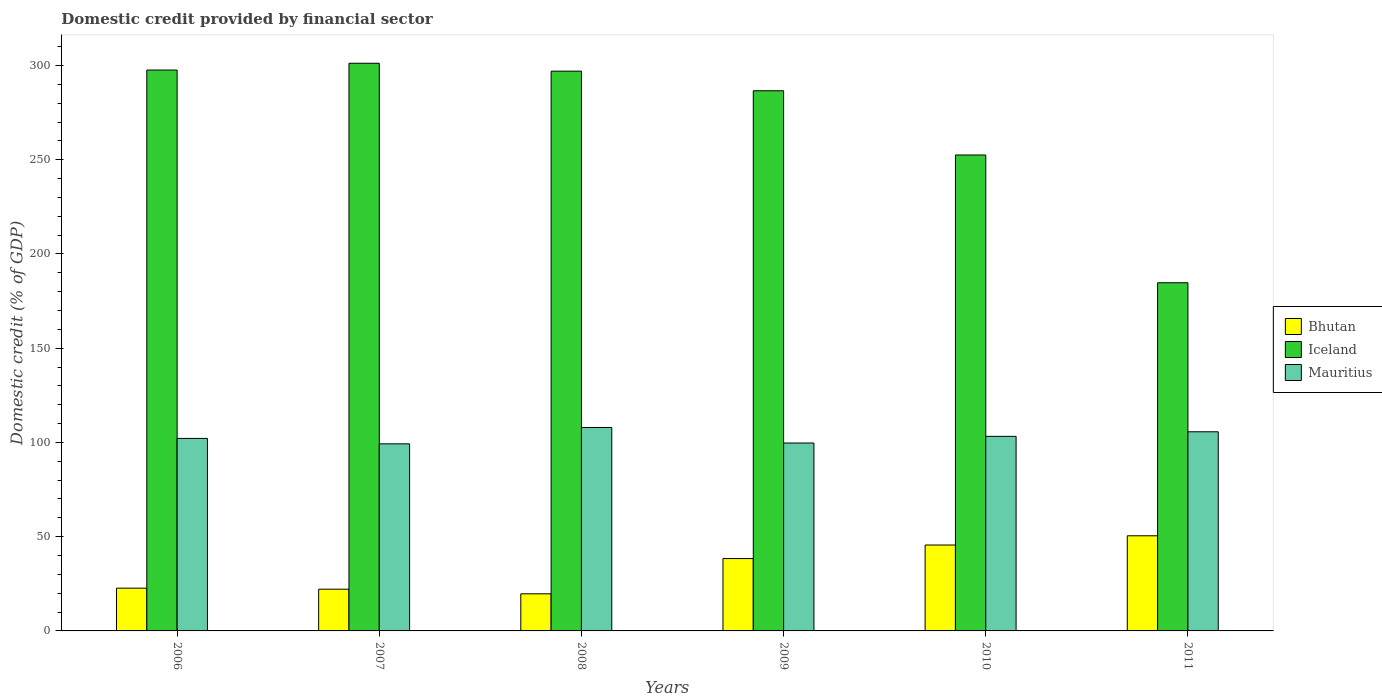How many different coloured bars are there?
Your response must be concise. 3. How many groups of bars are there?
Ensure brevity in your answer.  6. Are the number of bars per tick equal to the number of legend labels?
Your response must be concise. Yes. What is the domestic credit in Mauritius in 2011?
Your response must be concise. 105.66. Across all years, what is the maximum domestic credit in Bhutan?
Provide a succinct answer. 50.47. Across all years, what is the minimum domestic credit in Bhutan?
Offer a terse response. 19.68. In which year was the domestic credit in Mauritius maximum?
Your answer should be very brief. 2008. What is the total domestic credit in Mauritius in the graph?
Your answer should be compact. 617.94. What is the difference between the domestic credit in Iceland in 2006 and that in 2008?
Keep it short and to the point. 0.58. What is the difference between the domestic credit in Bhutan in 2009 and the domestic credit in Mauritius in 2006?
Your answer should be compact. -63.75. What is the average domestic credit in Bhutan per year?
Keep it short and to the point. 33.16. In the year 2006, what is the difference between the domestic credit in Mauritius and domestic credit in Bhutan?
Ensure brevity in your answer.  79.45. In how many years, is the domestic credit in Mauritius greater than 50 %?
Make the answer very short. 6. What is the ratio of the domestic credit in Mauritius in 2006 to that in 2010?
Provide a short and direct response. 0.99. Is the domestic credit in Bhutan in 2008 less than that in 2011?
Your answer should be very brief. Yes. Is the difference between the domestic credit in Mauritius in 2009 and 2011 greater than the difference between the domestic credit in Bhutan in 2009 and 2011?
Your answer should be compact. Yes. What is the difference between the highest and the second highest domestic credit in Iceland?
Your answer should be compact. 3.6. What is the difference between the highest and the lowest domestic credit in Bhutan?
Provide a short and direct response. 30.79. In how many years, is the domestic credit in Bhutan greater than the average domestic credit in Bhutan taken over all years?
Ensure brevity in your answer.  3. Is the sum of the domestic credit in Iceland in 2008 and 2011 greater than the maximum domestic credit in Bhutan across all years?
Give a very brief answer. Yes. What does the 1st bar from the left in 2009 represents?
Your answer should be compact. Bhutan. What does the 3rd bar from the right in 2006 represents?
Keep it short and to the point. Bhutan. Is it the case that in every year, the sum of the domestic credit in Bhutan and domestic credit in Iceland is greater than the domestic credit in Mauritius?
Make the answer very short. Yes. How many bars are there?
Give a very brief answer. 18. What is the difference between two consecutive major ticks on the Y-axis?
Provide a short and direct response. 50. Are the values on the major ticks of Y-axis written in scientific E-notation?
Give a very brief answer. No. Does the graph contain any zero values?
Your answer should be very brief. No. Where does the legend appear in the graph?
Make the answer very short. Center right. How many legend labels are there?
Keep it short and to the point. 3. How are the legend labels stacked?
Give a very brief answer. Vertical. What is the title of the graph?
Provide a succinct answer. Domestic credit provided by financial sector. What is the label or title of the Y-axis?
Ensure brevity in your answer.  Domestic credit (% of GDP). What is the Domestic credit (% of GDP) in Bhutan in 2006?
Ensure brevity in your answer.  22.69. What is the Domestic credit (% of GDP) of Iceland in 2006?
Offer a very short reply. 297.59. What is the Domestic credit (% of GDP) in Mauritius in 2006?
Keep it short and to the point. 102.14. What is the Domestic credit (% of GDP) in Bhutan in 2007?
Offer a very short reply. 22.15. What is the Domestic credit (% of GDP) in Iceland in 2007?
Offer a very short reply. 301.19. What is the Domestic credit (% of GDP) of Mauritius in 2007?
Offer a very short reply. 99.26. What is the Domestic credit (% of GDP) in Bhutan in 2008?
Offer a terse response. 19.68. What is the Domestic credit (% of GDP) of Iceland in 2008?
Keep it short and to the point. 297. What is the Domestic credit (% of GDP) in Mauritius in 2008?
Give a very brief answer. 107.94. What is the Domestic credit (% of GDP) in Bhutan in 2009?
Offer a very short reply. 38.38. What is the Domestic credit (% of GDP) of Iceland in 2009?
Keep it short and to the point. 286.6. What is the Domestic credit (% of GDP) in Mauritius in 2009?
Keep it short and to the point. 99.7. What is the Domestic credit (% of GDP) in Bhutan in 2010?
Give a very brief answer. 45.57. What is the Domestic credit (% of GDP) of Iceland in 2010?
Your answer should be compact. 252.52. What is the Domestic credit (% of GDP) in Mauritius in 2010?
Make the answer very short. 103.24. What is the Domestic credit (% of GDP) in Bhutan in 2011?
Your answer should be very brief. 50.47. What is the Domestic credit (% of GDP) of Iceland in 2011?
Ensure brevity in your answer.  184.73. What is the Domestic credit (% of GDP) of Mauritius in 2011?
Offer a terse response. 105.66. Across all years, what is the maximum Domestic credit (% of GDP) of Bhutan?
Your answer should be compact. 50.47. Across all years, what is the maximum Domestic credit (% of GDP) in Iceland?
Keep it short and to the point. 301.19. Across all years, what is the maximum Domestic credit (% of GDP) in Mauritius?
Provide a succinct answer. 107.94. Across all years, what is the minimum Domestic credit (% of GDP) in Bhutan?
Make the answer very short. 19.68. Across all years, what is the minimum Domestic credit (% of GDP) in Iceland?
Ensure brevity in your answer.  184.73. Across all years, what is the minimum Domestic credit (% of GDP) of Mauritius?
Provide a succinct answer. 99.26. What is the total Domestic credit (% of GDP) in Bhutan in the graph?
Provide a succinct answer. 198.95. What is the total Domestic credit (% of GDP) in Iceland in the graph?
Offer a terse response. 1619.63. What is the total Domestic credit (% of GDP) in Mauritius in the graph?
Your response must be concise. 617.94. What is the difference between the Domestic credit (% of GDP) in Bhutan in 2006 and that in 2007?
Keep it short and to the point. 0.54. What is the difference between the Domestic credit (% of GDP) of Iceland in 2006 and that in 2007?
Give a very brief answer. -3.6. What is the difference between the Domestic credit (% of GDP) in Mauritius in 2006 and that in 2007?
Provide a short and direct response. 2.88. What is the difference between the Domestic credit (% of GDP) in Bhutan in 2006 and that in 2008?
Your answer should be very brief. 3.01. What is the difference between the Domestic credit (% of GDP) of Iceland in 2006 and that in 2008?
Give a very brief answer. 0.58. What is the difference between the Domestic credit (% of GDP) of Mauritius in 2006 and that in 2008?
Provide a short and direct response. -5.8. What is the difference between the Domestic credit (% of GDP) in Bhutan in 2006 and that in 2009?
Offer a terse response. -15.7. What is the difference between the Domestic credit (% of GDP) in Iceland in 2006 and that in 2009?
Offer a very short reply. 10.99. What is the difference between the Domestic credit (% of GDP) in Mauritius in 2006 and that in 2009?
Provide a succinct answer. 2.44. What is the difference between the Domestic credit (% of GDP) in Bhutan in 2006 and that in 2010?
Your answer should be compact. -22.88. What is the difference between the Domestic credit (% of GDP) of Iceland in 2006 and that in 2010?
Keep it short and to the point. 45.07. What is the difference between the Domestic credit (% of GDP) of Mauritius in 2006 and that in 2010?
Provide a short and direct response. -1.1. What is the difference between the Domestic credit (% of GDP) in Bhutan in 2006 and that in 2011?
Your answer should be compact. -27.79. What is the difference between the Domestic credit (% of GDP) of Iceland in 2006 and that in 2011?
Ensure brevity in your answer.  112.86. What is the difference between the Domestic credit (% of GDP) of Mauritius in 2006 and that in 2011?
Offer a terse response. -3.52. What is the difference between the Domestic credit (% of GDP) of Bhutan in 2007 and that in 2008?
Provide a short and direct response. 2.47. What is the difference between the Domestic credit (% of GDP) of Iceland in 2007 and that in 2008?
Offer a very short reply. 4.18. What is the difference between the Domestic credit (% of GDP) of Mauritius in 2007 and that in 2008?
Offer a very short reply. -8.68. What is the difference between the Domestic credit (% of GDP) of Bhutan in 2007 and that in 2009?
Your answer should be compact. -16.24. What is the difference between the Domestic credit (% of GDP) in Iceland in 2007 and that in 2009?
Offer a terse response. 14.59. What is the difference between the Domestic credit (% of GDP) of Mauritius in 2007 and that in 2009?
Keep it short and to the point. -0.44. What is the difference between the Domestic credit (% of GDP) in Bhutan in 2007 and that in 2010?
Make the answer very short. -23.43. What is the difference between the Domestic credit (% of GDP) in Iceland in 2007 and that in 2010?
Make the answer very short. 48.67. What is the difference between the Domestic credit (% of GDP) of Mauritius in 2007 and that in 2010?
Your answer should be very brief. -3.98. What is the difference between the Domestic credit (% of GDP) in Bhutan in 2007 and that in 2011?
Ensure brevity in your answer.  -28.33. What is the difference between the Domestic credit (% of GDP) of Iceland in 2007 and that in 2011?
Make the answer very short. 116.46. What is the difference between the Domestic credit (% of GDP) of Mauritius in 2007 and that in 2011?
Ensure brevity in your answer.  -6.4. What is the difference between the Domestic credit (% of GDP) in Bhutan in 2008 and that in 2009?
Give a very brief answer. -18.7. What is the difference between the Domestic credit (% of GDP) of Iceland in 2008 and that in 2009?
Ensure brevity in your answer.  10.41. What is the difference between the Domestic credit (% of GDP) in Mauritius in 2008 and that in 2009?
Your answer should be very brief. 8.24. What is the difference between the Domestic credit (% of GDP) in Bhutan in 2008 and that in 2010?
Offer a very short reply. -25.89. What is the difference between the Domestic credit (% of GDP) in Iceland in 2008 and that in 2010?
Offer a very short reply. 44.48. What is the difference between the Domestic credit (% of GDP) in Mauritius in 2008 and that in 2010?
Ensure brevity in your answer.  4.7. What is the difference between the Domestic credit (% of GDP) in Bhutan in 2008 and that in 2011?
Make the answer very short. -30.79. What is the difference between the Domestic credit (% of GDP) in Iceland in 2008 and that in 2011?
Ensure brevity in your answer.  112.27. What is the difference between the Domestic credit (% of GDP) of Mauritius in 2008 and that in 2011?
Provide a short and direct response. 2.28. What is the difference between the Domestic credit (% of GDP) in Bhutan in 2009 and that in 2010?
Keep it short and to the point. -7.19. What is the difference between the Domestic credit (% of GDP) of Iceland in 2009 and that in 2010?
Offer a terse response. 34.07. What is the difference between the Domestic credit (% of GDP) of Mauritius in 2009 and that in 2010?
Your answer should be compact. -3.53. What is the difference between the Domestic credit (% of GDP) of Bhutan in 2009 and that in 2011?
Offer a very short reply. -12.09. What is the difference between the Domestic credit (% of GDP) of Iceland in 2009 and that in 2011?
Offer a very short reply. 101.86. What is the difference between the Domestic credit (% of GDP) of Mauritius in 2009 and that in 2011?
Offer a terse response. -5.96. What is the difference between the Domestic credit (% of GDP) in Bhutan in 2010 and that in 2011?
Offer a very short reply. -4.9. What is the difference between the Domestic credit (% of GDP) in Iceland in 2010 and that in 2011?
Make the answer very short. 67.79. What is the difference between the Domestic credit (% of GDP) in Mauritius in 2010 and that in 2011?
Your response must be concise. -2.43. What is the difference between the Domestic credit (% of GDP) in Bhutan in 2006 and the Domestic credit (% of GDP) in Iceland in 2007?
Make the answer very short. -278.5. What is the difference between the Domestic credit (% of GDP) in Bhutan in 2006 and the Domestic credit (% of GDP) in Mauritius in 2007?
Offer a very short reply. -76.57. What is the difference between the Domestic credit (% of GDP) in Iceland in 2006 and the Domestic credit (% of GDP) in Mauritius in 2007?
Your response must be concise. 198.33. What is the difference between the Domestic credit (% of GDP) of Bhutan in 2006 and the Domestic credit (% of GDP) of Iceland in 2008?
Your response must be concise. -274.32. What is the difference between the Domestic credit (% of GDP) in Bhutan in 2006 and the Domestic credit (% of GDP) in Mauritius in 2008?
Offer a very short reply. -85.25. What is the difference between the Domestic credit (% of GDP) in Iceland in 2006 and the Domestic credit (% of GDP) in Mauritius in 2008?
Keep it short and to the point. 189.65. What is the difference between the Domestic credit (% of GDP) in Bhutan in 2006 and the Domestic credit (% of GDP) in Iceland in 2009?
Provide a succinct answer. -263.91. What is the difference between the Domestic credit (% of GDP) in Bhutan in 2006 and the Domestic credit (% of GDP) in Mauritius in 2009?
Offer a terse response. -77.01. What is the difference between the Domestic credit (% of GDP) of Iceland in 2006 and the Domestic credit (% of GDP) of Mauritius in 2009?
Ensure brevity in your answer.  197.89. What is the difference between the Domestic credit (% of GDP) of Bhutan in 2006 and the Domestic credit (% of GDP) of Iceland in 2010?
Give a very brief answer. -229.83. What is the difference between the Domestic credit (% of GDP) of Bhutan in 2006 and the Domestic credit (% of GDP) of Mauritius in 2010?
Offer a very short reply. -80.55. What is the difference between the Domestic credit (% of GDP) in Iceland in 2006 and the Domestic credit (% of GDP) in Mauritius in 2010?
Your response must be concise. 194.35. What is the difference between the Domestic credit (% of GDP) of Bhutan in 2006 and the Domestic credit (% of GDP) of Iceland in 2011?
Provide a succinct answer. -162.04. What is the difference between the Domestic credit (% of GDP) in Bhutan in 2006 and the Domestic credit (% of GDP) in Mauritius in 2011?
Keep it short and to the point. -82.97. What is the difference between the Domestic credit (% of GDP) of Iceland in 2006 and the Domestic credit (% of GDP) of Mauritius in 2011?
Provide a short and direct response. 191.93. What is the difference between the Domestic credit (% of GDP) of Bhutan in 2007 and the Domestic credit (% of GDP) of Iceland in 2008?
Make the answer very short. -274.86. What is the difference between the Domestic credit (% of GDP) in Bhutan in 2007 and the Domestic credit (% of GDP) in Mauritius in 2008?
Provide a short and direct response. -85.79. What is the difference between the Domestic credit (% of GDP) in Iceland in 2007 and the Domestic credit (% of GDP) in Mauritius in 2008?
Make the answer very short. 193.25. What is the difference between the Domestic credit (% of GDP) of Bhutan in 2007 and the Domestic credit (% of GDP) of Iceland in 2009?
Keep it short and to the point. -264.45. What is the difference between the Domestic credit (% of GDP) of Bhutan in 2007 and the Domestic credit (% of GDP) of Mauritius in 2009?
Make the answer very short. -77.56. What is the difference between the Domestic credit (% of GDP) of Iceland in 2007 and the Domestic credit (% of GDP) of Mauritius in 2009?
Give a very brief answer. 201.49. What is the difference between the Domestic credit (% of GDP) of Bhutan in 2007 and the Domestic credit (% of GDP) of Iceland in 2010?
Offer a very short reply. -230.37. What is the difference between the Domestic credit (% of GDP) in Bhutan in 2007 and the Domestic credit (% of GDP) in Mauritius in 2010?
Provide a succinct answer. -81.09. What is the difference between the Domestic credit (% of GDP) in Iceland in 2007 and the Domestic credit (% of GDP) in Mauritius in 2010?
Your answer should be very brief. 197.95. What is the difference between the Domestic credit (% of GDP) in Bhutan in 2007 and the Domestic credit (% of GDP) in Iceland in 2011?
Offer a terse response. -162.59. What is the difference between the Domestic credit (% of GDP) of Bhutan in 2007 and the Domestic credit (% of GDP) of Mauritius in 2011?
Keep it short and to the point. -83.52. What is the difference between the Domestic credit (% of GDP) of Iceland in 2007 and the Domestic credit (% of GDP) of Mauritius in 2011?
Ensure brevity in your answer.  195.52. What is the difference between the Domestic credit (% of GDP) of Bhutan in 2008 and the Domestic credit (% of GDP) of Iceland in 2009?
Keep it short and to the point. -266.91. What is the difference between the Domestic credit (% of GDP) in Bhutan in 2008 and the Domestic credit (% of GDP) in Mauritius in 2009?
Your response must be concise. -80.02. What is the difference between the Domestic credit (% of GDP) in Iceland in 2008 and the Domestic credit (% of GDP) in Mauritius in 2009?
Your answer should be compact. 197.3. What is the difference between the Domestic credit (% of GDP) in Bhutan in 2008 and the Domestic credit (% of GDP) in Iceland in 2010?
Provide a short and direct response. -232.84. What is the difference between the Domestic credit (% of GDP) of Bhutan in 2008 and the Domestic credit (% of GDP) of Mauritius in 2010?
Your answer should be very brief. -83.56. What is the difference between the Domestic credit (% of GDP) of Iceland in 2008 and the Domestic credit (% of GDP) of Mauritius in 2010?
Your answer should be compact. 193.77. What is the difference between the Domestic credit (% of GDP) in Bhutan in 2008 and the Domestic credit (% of GDP) in Iceland in 2011?
Offer a terse response. -165.05. What is the difference between the Domestic credit (% of GDP) in Bhutan in 2008 and the Domestic credit (% of GDP) in Mauritius in 2011?
Your answer should be very brief. -85.98. What is the difference between the Domestic credit (% of GDP) of Iceland in 2008 and the Domestic credit (% of GDP) of Mauritius in 2011?
Keep it short and to the point. 191.34. What is the difference between the Domestic credit (% of GDP) in Bhutan in 2009 and the Domestic credit (% of GDP) in Iceland in 2010?
Ensure brevity in your answer.  -214.14. What is the difference between the Domestic credit (% of GDP) of Bhutan in 2009 and the Domestic credit (% of GDP) of Mauritius in 2010?
Provide a short and direct response. -64.85. What is the difference between the Domestic credit (% of GDP) of Iceland in 2009 and the Domestic credit (% of GDP) of Mauritius in 2010?
Provide a short and direct response. 183.36. What is the difference between the Domestic credit (% of GDP) in Bhutan in 2009 and the Domestic credit (% of GDP) in Iceland in 2011?
Ensure brevity in your answer.  -146.35. What is the difference between the Domestic credit (% of GDP) of Bhutan in 2009 and the Domestic credit (% of GDP) of Mauritius in 2011?
Your answer should be compact. -67.28. What is the difference between the Domestic credit (% of GDP) of Iceland in 2009 and the Domestic credit (% of GDP) of Mauritius in 2011?
Provide a short and direct response. 180.93. What is the difference between the Domestic credit (% of GDP) of Bhutan in 2010 and the Domestic credit (% of GDP) of Iceland in 2011?
Keep it short and to the point. -139.16. What is the difference between the Domestic credit (% of GDP) of Bhutan in 2010 and the Domestic credit (% of GDP) of Mauritius in 2011?
Keep it short and to the point. -60.09. What is the difference between the Domestic credit (% of GDP) of Iceland in 2010 and the Domestic credit (% of GDP) of Mauritius in 2011?
Offer a very short reply. 146.86. What is the average Domestic credit (% of GDP) in Bhutan per year?
Offer a terse response. 33.16. What is the average Domestic credit (% of GDP) of Iceland per year?
Offer a very short reply. 269.94. What is the average Domestic credit (% of GDP) of Mauritius per year?
Provide a succinct answer. 102.99. In the year 2006, what is the difference between the Domestic credit (% of GDP) in Bhutan and Domestic credit (% of GDP) in Iceland?
Offer a very short reply. -274.9. In the year 2006, what is the difference between the Domestic credit (% of GDP) of Bhutan and Domestic credit (% of GDP) of Mauritius?
Give a very brief answer. -79.45. In the year 2006, what is the difference between the Domestic credit (% of GDP) of Iceland and Domestic credit (% of GDP) of Mauritius?
Offer a very short reply. 195.45. In the year 2007, what is the difference between the Domestic credit (% of GDP) in Bhutan and Domestic credit (% of GDP) in Iceland?
Make the answer very short. -279.04. In the year 2007, what is the difference between the Domestic credit (% of GDP) of Bhutan and Domestic credit (% of GDP) of Mauritius?
Keep it short and to the point. -77.11. In the year 2007, what is the difference between the Domestic credit (% of GDP) in Iceland and Domestic credit (% of GDP) in Mauritius?
Keep it short and to the point. 201.93. In the year 2008, what is the difference between the Domestic credit (% of GDP) in Bhutan and Domestic credit (% of GDP) in Iceland?
Make the answer very short. -277.32. In the year 2008, what is the difference between the Domestic credit (% of GDP) of Bhutan and Domestic credit (% of GDP) of Mauritius?
Keep it short and to the point. -88.26. In the year 2008, what is the difference between the Domestic credit (% of GDP) of Iceland and Domestic credit (% of GDP) of Mauritius?
Provide a short and direct response. 189.06. In the year 2009, what is the difference between the Domestic credit (% of GDP) of Bhutan and Domestic credit (% of GDP) of Iceland?
Offer a very short reply. -248.21. In the year 2009, what is the difference between the Domestic credit (% of GDP) in Bhutan and Domestic credit (% of GDP) in Mauritius?
Offer a terse response. -61.32. In the year 2009, what is the difference between the Domestic credit (% of GDP) of Iceland and Domestic credit (% of GDP) of Mauritius?
Offer a terse response. 186.89. In the year 2010, what is the difference between the Domestic credit (% of GDP) of Bhutan and Domestic credit (% of GDP) of Iceland?
Offer a very short reply. -206.95. In the year 2010, what is the difference between the Domestic credit (% of GDP) of Bhutan and Domestic credit (% of GDP) of Mauritius?
Your answer should be compact. -57.67. In the year 2010, what is the difference between the Domestic credit (% of GDP) in Iceland and Domestic credit (% of GDP) in Mauritius?
Your response must be concise. 149.28. In the year 2011, what is the difference between the Domestic credit (% of GDP) of Bhutan and Domestic credit (% of GDP) of Iceland?
Provide a short and direct response. -134.26. In the year 2011, what is the difference between the Domestic credit (% of GDP) of Bhutan and Domestic credit (% of GDP) of Mauritius?
Provide a succinct answer. -55.19. In the year 2011, what is the difference between the Domestic credit (% of GDP) in Iceland and Domestic credit (% of GDP) in Mauritius?
Provide a short and direct response. 79.07. What is the ratio of the Domestic credit (% of GDP) in Bhutan in 2006 to that in 2007?
Your response must be concise. 1.02. What is the ratio of the Domestic credit (% of GDP) in Iceland in 2006 to that in 2007?
Ensure brevity in your answer.  0.99. What is the ratio of the Domestic credit (% of GDP) of Mauritius in 2006 to that in 2007?
Provide a succinct answer. 1.03. What is the ratio of the Domestic credit (% of GDP) of Bhutan in 2006 to that in 2008?
Provide a short and direct response. 1.15. What is the ratio of the Domestic credit (% of GDP) in Mauritius in 2006 to that in 2008?
Ensure brevity in your answer.  0.95. What is the ratio of the Domestic credit (% of GDP) in Bhutan in 2006 to that in 2009?
Offer a very short reply. 0.59. What is the ratio of the Domestic credit (% of GDP) in Iceland in 2006 to that in 2009?
Your answer should be very brief. 1.04. What is the ratio of the Domestic credit (% of GDP) in Mauritius in 2006 to that in 2009?
Keep it short and to the point. 1.02. What is the ratio of the Domestic credit (% of GDP) of Bhutan in 2006 to that in 2010?
Offer a very short reply. 0.5. What is the ratio of the Domestic credit (% of GDP) of Iceland in 2006 to that in 2010?
Offer a terse response. 1.18. What is the ratio of the Domestic credit (% of GDP) in Bhutan in 2006 to that in 2011?
Your answer should be very brief. 0.45. What is the ratio of the Domestic credit (% of GDP) in Iceland in 2006 to that in 2011?
Offer a very short reply. 1.61. What is the ratio of the Domestic credit (% of GDP) of Mauritius in 2006 to that in 2011?
Offer a very short reply. 0.97. What is the ratio of the Domestic credit (% of GDP) in Bhutan in 2007 to that in 2008?
Your answer should be very brief. 1.13. What is the ratio of the Domestic credit (% of GDP) of Iceland in 2007 to that in 2008?
Keep it short and to the point. 1.01. What is the ratio of the Domestic credit (% of GDP) of Mauritius in 2007 to that in 2008?
Your response must be concise. 0.92. What is the ratio of the Domestic credit (% of GDP) of Bhutan in 2007 to that in 2009?
Ensure brevity in your answer.  0.58. What is the ratio of the Domestic credit (% of GDP) in Iceland in 2007 to that in 2009?
Your answer should be compact. 1.05. What is the ratio of the Domestic credit (% of GDP) of Mauritius in 2007 to that in 2009?
Your response must be concise. 1. What is the ratio of the Domestic credit (% of GDP) of Bhutan in 2007 to that in 2010?
Your answer should be compact. 0.49. What is the ratio of the Domestic credit (% of GDP) in Iceland in 2007 to that in 2010?
Provide a short and direct response. 1.19. What is the ratio of the Domestic credit (% of GDP) of Mauritius in 2007 to that in 2010?
Offer a terse response. 0.96. What is the ratio of the Domestic credit (% of GDP) in Bhutan in 2007 to that in 2011?
Offer a terse response. 0.44. What is the ratio of the Domestic credit (% of GDP) of Iceland in 2007 to that in 2011?
Offer a very short reply. 1.63. What is the ratio of the Domestic credit (% of GDP) of Mauritius in 2007 to that in 2011?
Provide a succinct answer. 0.94. What is the ratio of the Domestic credit (% of GDP) of Bhutan in 2008 to that in 2009?
Ensure brevity in your answer.  0.51. What is the ratio of the Domestic credit (% of GDP) in Iceland in 2008 to that in 2009?
Your answer should be very brief. 1.04. What is the ratio of the Domestic credit (% of GDP) of Mauritius in 2008 to that in 2009?
Your answer should be very brief. 1.08. What is the ratio of the Domestic credit (% of GDP) of Bhutan in 2008 to that in 2010?
Make the answer very short. 0.43. What is the ratio of the Domestic credit (% of GDP) of Iceland in 2008 to that in 2010?
Give a very brief answer. 1.18. What is the ratio of the Domestic credit (% of GDP) of Mauritius in 2008 to that in 2010?
Make the answer very short. 1.05. What is the ratio of the Domestic credit (% of GDP) in Bhutan in 2008 to that in 2011?
Your response must be concise. 0.39. What is the ratio of the Domestic credit (% of GDP) of Iceland in 2008 to that in 2011?
Ensure brevity in your answer.  1.61. What is the ratio of the Domestic credit (% of GDP) of Mauritius in 2008 to that in 2011?
Your response must be concise. 1.02. What is the ratio of the Domestic credit (% of GDP) in Bhutan in 2009 to that in 2010?
Offer a very short reply. 0.84. What is the ratio of the Domestic credit (% of GDP) in Iceland in 2009 to that in 2010?
Your response must be concise. 1.13. What is the ratio of the Domestic credit (% of GDP) in Mauritius in 2009 to that in 2010?
Keep it short and to the point. 0.97. What is the ratio of the Domestic credit (% of GDP) in Bhutan in 2009 to that in 2011?
Provide a short and direct response. 0.76. What is the ratio of the Domestic credit (% of GDP) of Iceland in 2009 to that in 2011?
Give a very brief answer. 1.55. What is the ratio of the Domestic credit (% of GDP) in Mauritius in 2009 to that in 2011?
Your response must be concise. 0.94. What is the ratio of the Domestic credit (% of GDP) of Bhutan in 2010 to that in 2011?
Your answer should be compact. 0.9. What is the ratio of the Domestic credit (% of GDP) in Iceland in 2010 to that in 2011?
Offer a terse response. 1.37. What is the ratio of the Domestic credit (% of GDP) of Mauritius in 2010 to that in 2011?
Offer a very short reply. 0.98. What is the difference between the highest and the second highest Domestic credit (% of GDP) of Bhutan?
Provide a succinct answer. 4.9. What is the difference between the highest and the second highest Domestic credit (% of GDP) of Iceland?
Ensure brevity in your answer.  3.6. What is the difference between the highest and the second highest Domestic credit (% of GDP) in Mauritius?
Offer a very short reply. 2.28. What is the difference between the highest and the lowest Domestic credit (% of GDP) of Bhutan?
Make the answer very short. 30.79. What is the difference between the highest and the lowest Domestic credit (% of GDP) of Iceland?
Make the answer very short. 116.46. What is the difference between the highest and the lowest Domestic credit (% of GDP) of Mauritius?
Your answer should be very brief. 8.68. 